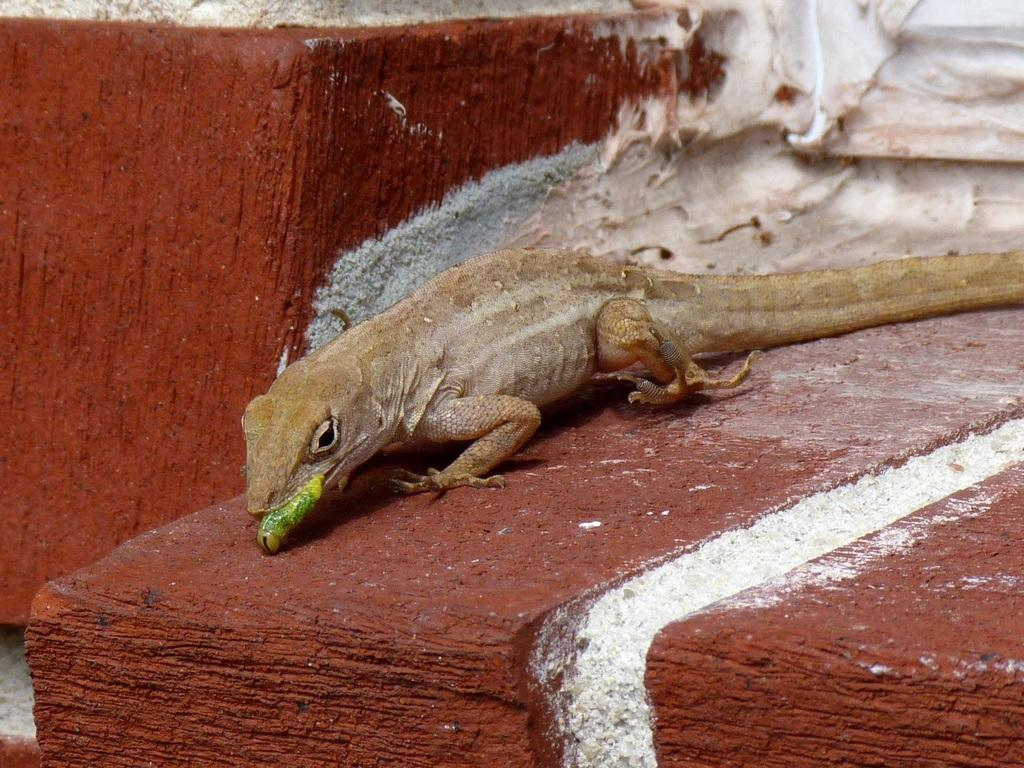What type of animal is in the picture? There is a lizard in the picture. What is the lizard holding in its mouth? The lizard has a green object in its mouth. Can you describe any other colors present in the image? Yes, there are red and white objects visible in the image. What type of bird can be seen flying in the image? There is no bird visible in the image; it features a lizard with a green object in its mouth and red and white objects. 